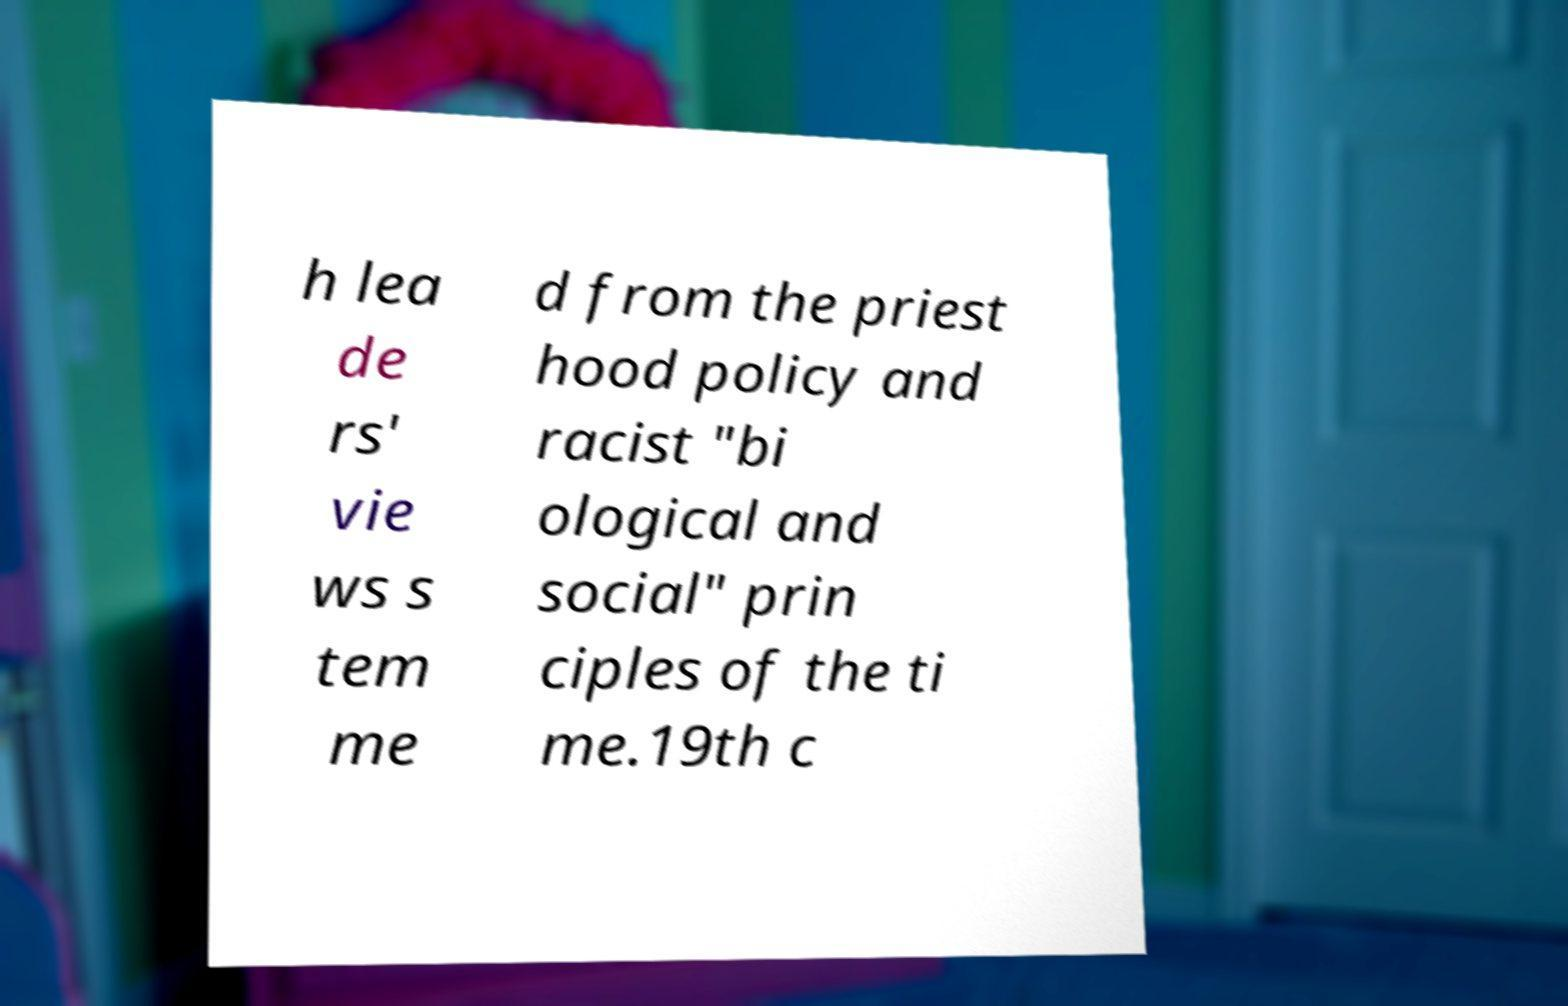Can you read and provide the text displayed in the image?This photo seems to have some interesting text. Can you extract and type it out for me? h lea de rs' vie ws s tem me d from the priest hood policy and racist "bi ological and social" prin ciples of the ti me.19th c 